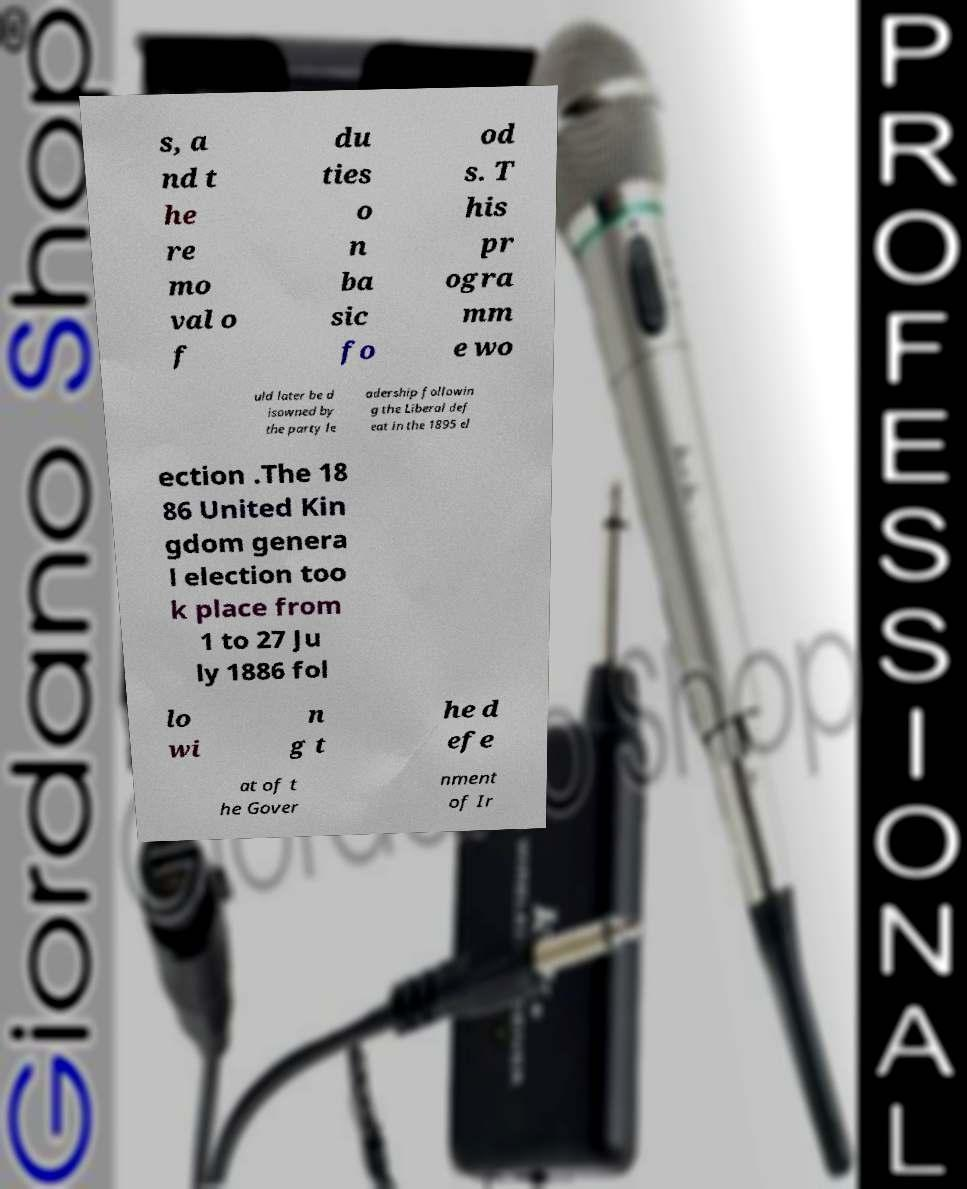Please identify and transcribe the text found in this image. s, a nd t he re mo val o f du ties o n ba sic fo od s. T his pr ogra mm e wo uld later be d isowned by the party le adership followin g the Liberal def eat in the 1895 el ection .The 18 86 United Kin gdom genera l election too k place from 1 to 27 Ju ly 1886 fol lo wi n g t he d efe at of t he Gover nment of Ir 